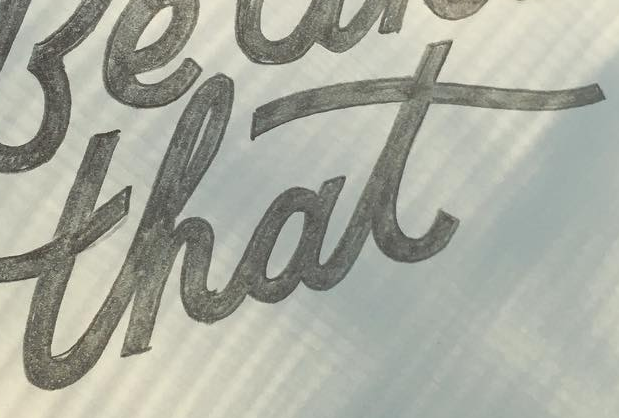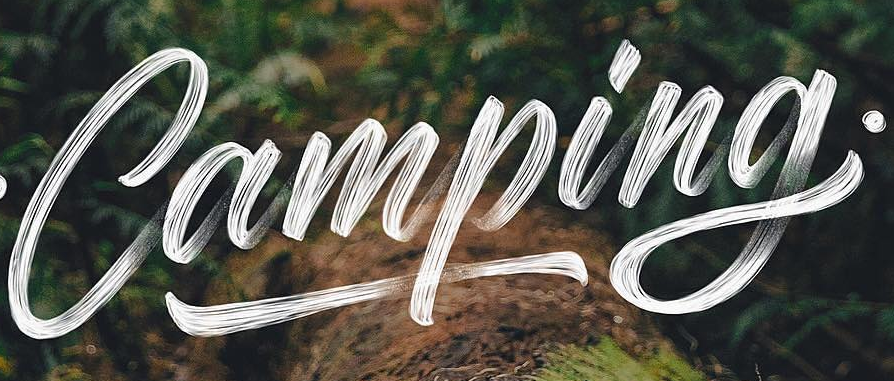What words are shown in these images in order, separated by a semicolon? that; Camping 